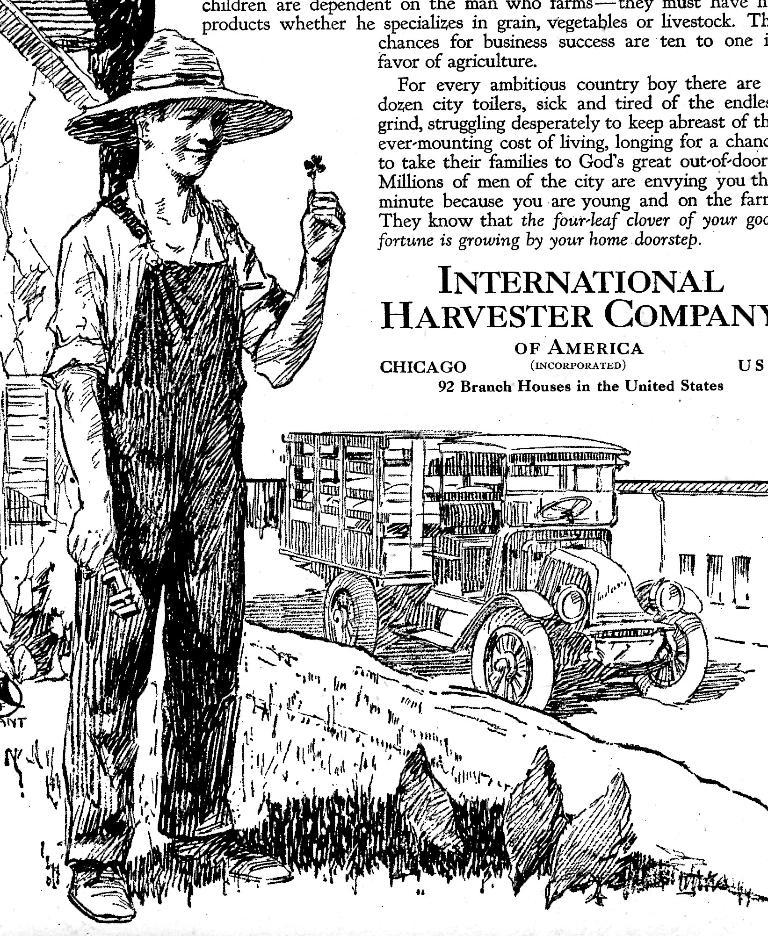What is the main subject of the image? There is a person standing in the image. What is the person holding in the image? The person is holding something. What can be seen in the background of the image? There is a vehicle, a building, windows, and writing on an object visible in the background. What type of nut is being combed in the image? There is no nut or comb present in the image. What kind of bread can be seen in the image? There is no bread visible in the image. 